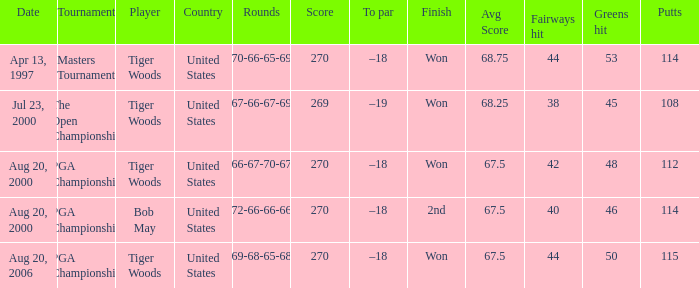What is the worst (highest) score? 270.0. 